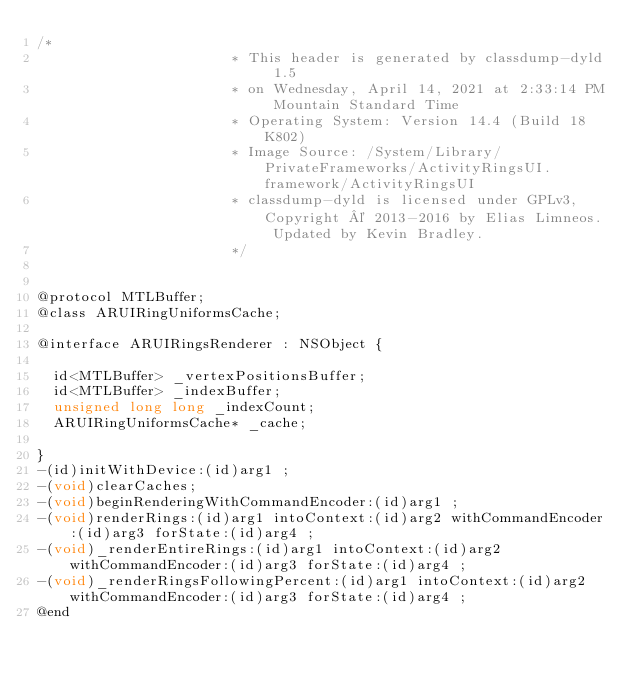<code> <loc_0><loc_0><loc_500><loc_500><_C_>/*
                       * This header is generated by classdump-dyld 1.5
                       * on Wednesday, April 14, 2021 at 2:33:14 PM Mountain Standard Time
                       * Operating System: Version 14.4 (Build 18K802)
                       * Image Source: /System/Library/PrivateFrameworks/ActivityRingsUI.framework/ActivityRingsUI
                       * classdump-dyld is licensed under GPLv3, Copyright © 2013-2016 by Elias Limneos. Updated by Kevin Bradley.
                       */


@protocol MTLBuffer;
@class ARUIRingUniformsCache;

@interface ARUIRingsRenderer : NSObject {

	id<MTLBuffer> _vertexPositionsBuffer;
	id<MTLBuffer> _indexBuffer;
	unsigned long long _indexCount;
	ARUIRingUniformsCache* _cache;

}
-(id)initWithDevice:(id)arg1 ;
-(void)clearCaches;
-(void)beginRenderingWithCommandEncoder:(id)arg1 ;
-(void)renderRings:(id)arg1 intoContext:(id)arg2 withCommandEncoder:(id)arg3 forState:(id)arg4 ;
-(void)_renderEntireRings:(id)arg1 intoContext:(id)arg2 withCommandEncoder:(id)arg3 forState:(id)arg4 ;
-(void)_renderRingsFollowingPercent:(id)arg1 intoContext:(id)arg2 withCommandEncoder:(id)arg3 forState:(id)arg4 ;
@end

</code> 